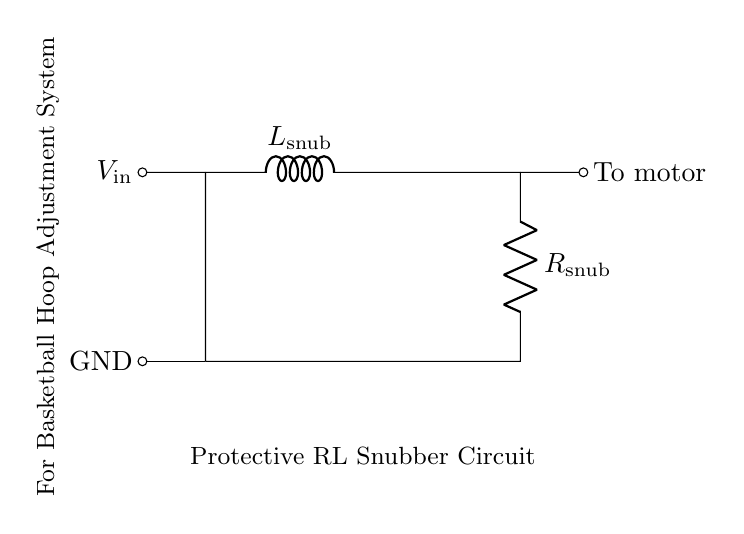What components are in the snubber circuit? The circuit contains an inductor labeled L snub and a resistor labeled R snub.
Answer: L snub, R snub What is the purpose of the inductor in this circuit? The inductor absorbs voltage spikes, which helps protect the motor and extends its lifespan.
Answer: Absorb voltage spikes What is the connection point for the motor? The motor is connected to the right side of the resistor, indicated as "To motor."
Answer: To motor How is the circuit powered? The circuit is powered by the input voltage labeled V in at the left side of the inductor.
Answer: V in What does the GND notation signify? The GND notation indicates the ground reference point for the circuit, connecting to the negative side of the voltage supply.
Answer: Ground reference Why is an RL snubber circuit chosen for this application? An RL snubber circuit is effective in damping oscillations and protecting against back EMF from the motor's operation.
Answer: Damping oscillations 